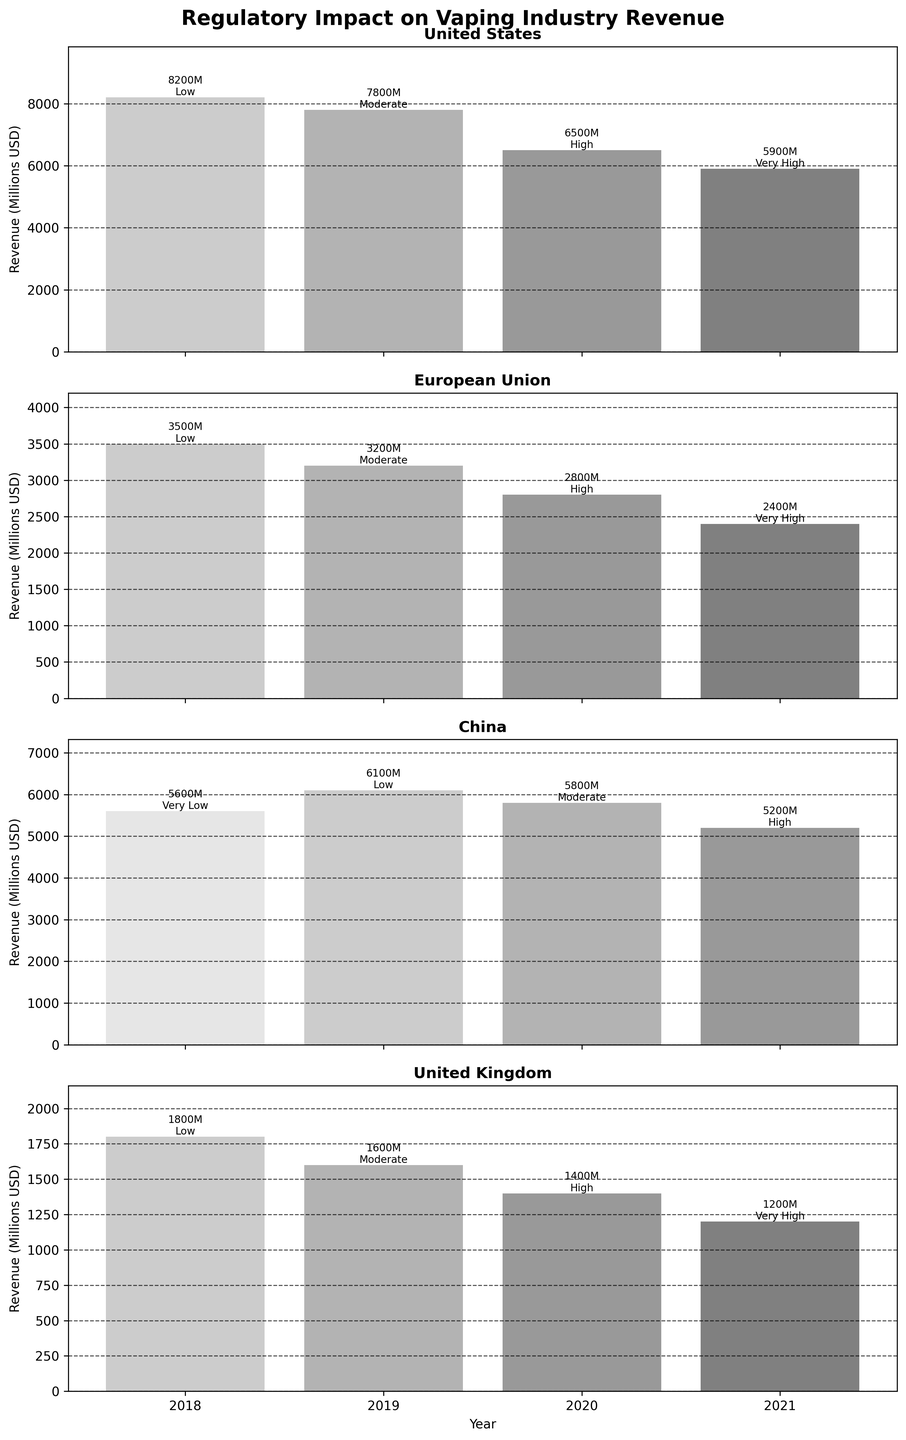What is the trend in revenue for the United States from 2018 to 2021? To determine this, we look at the bars for the United States subplot from 2018 to 2021. The revenue decreases from 8200 million USD in 2018 to 5900 million USD in 2021.
Answer: Decreasing Which region has the highest revenue in 2019? To find this, we compare the height of the bars for all regions in the year 2019. The tallest bar represents China with 6100 million USD.
Answer: China How did the revenue change in the European Union from 2018 to 2021? The bars for the European Union show a consistent decrease in revenue from 3500 million USD in 2018 to 2400 million USD in 2021.
Answer: Decreasing What is the average revenue for the United Kingdom from 2018 to 2021? Sum the revenues from 2018 to 2021 (1800 + 1600 + 1400 + 1200) and divide by the number of years (4). The calculation is (1800 + 1600 + 1400 + 1200) / 4 = 1500 million USD.
Answer: 1500 million USD Which region faced the highest regulatory impact in 2021, and what was it? Checking the regulatory impact for all regions in 2021, all regions except China have a 'Very High' impact. Thus, both the United States, European Union, and United Kingdom faced the highest regulatory impact in 2021 with 'Very High'.
Answer: United States, European Union, United Kingdom, Very High What is the revenue trend for China from 2018 to 2021 and its corresponding regulatory impacts? The revenue in China is 5600 million USD in 2018, increases to 6100 in 2019, then decreases to 5800 in 2020, and further down to 5200 in 2021. Corresponding regulatory impacts are 'Very Low' in 2018, 'Low' in 2019, 'Moderate' in 2020, and 'High' in 2021.
Answer: Increase from 2018 to 2019, then decrease, Regulatory impacts: Very Low, Low, Moderate, High Compare the revenue in 2018 and 2021 for all regions. Which region has the least reduction? Calculate the difference between 2018 and 2021 revenue for all regions: United States (8200 - 5900 = 2300), European Union (3500 - 2400 = 1100), China (5600 - 5200 = 400), United Kingdom (1800 - 1200 = 600). China has the least reduction in revenue.
Answer: China What is the sum of revenues across all regions for the year 2020? Sum the revenue values for all regions in 2020: United States (6500) + European Union (2800) + China (5800) + United Kingdom (1400). The total is 6500 + 2800 + 5800 + 1400 = 16500 million USD.
Answer: 16500 million USD 